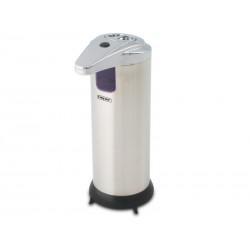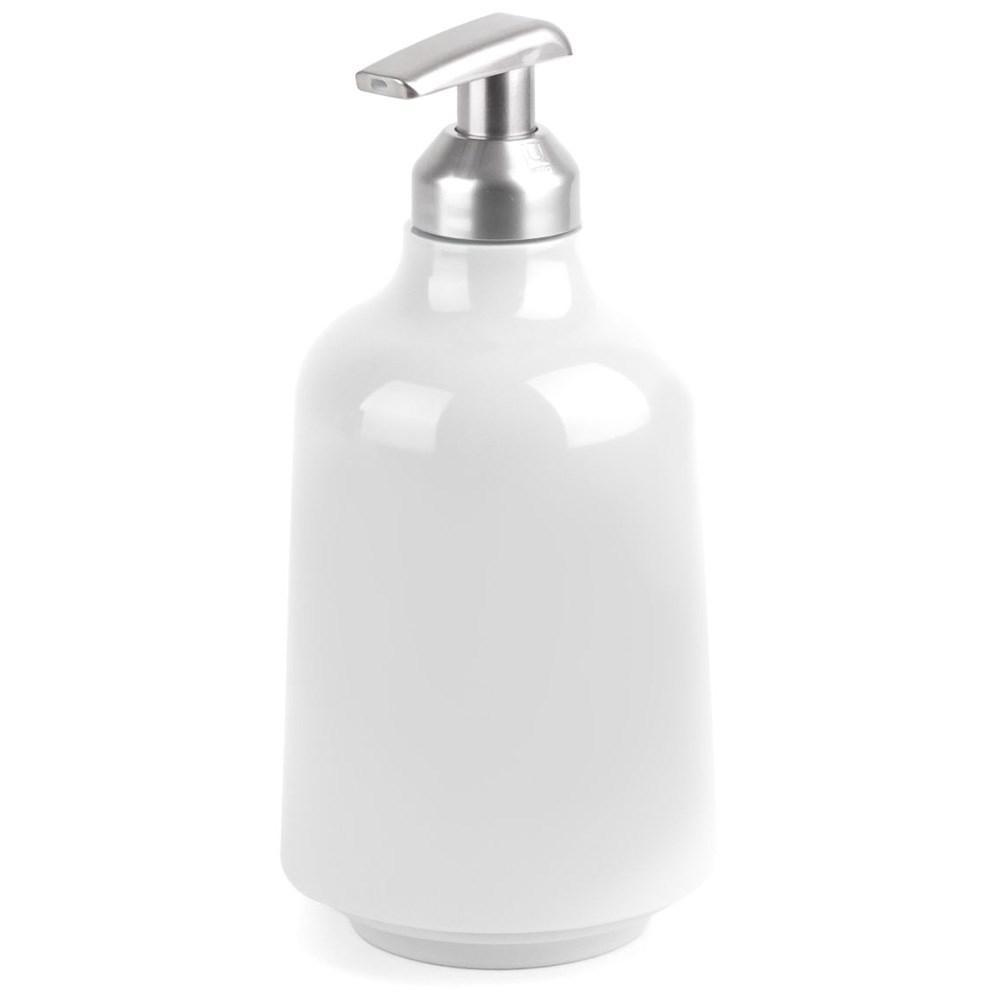The first image is the image on the left, the second image is the image on the right. For the images shown, is this caption "The dispenser on the left is rectangular in shape." true? Answer yes or no. No. The first image is the image on the left, the second image is the image on the right. Given the left and right images, does the statement "The dispenser in the image on the right is round" hold true? Answer yes or no. Yes. 